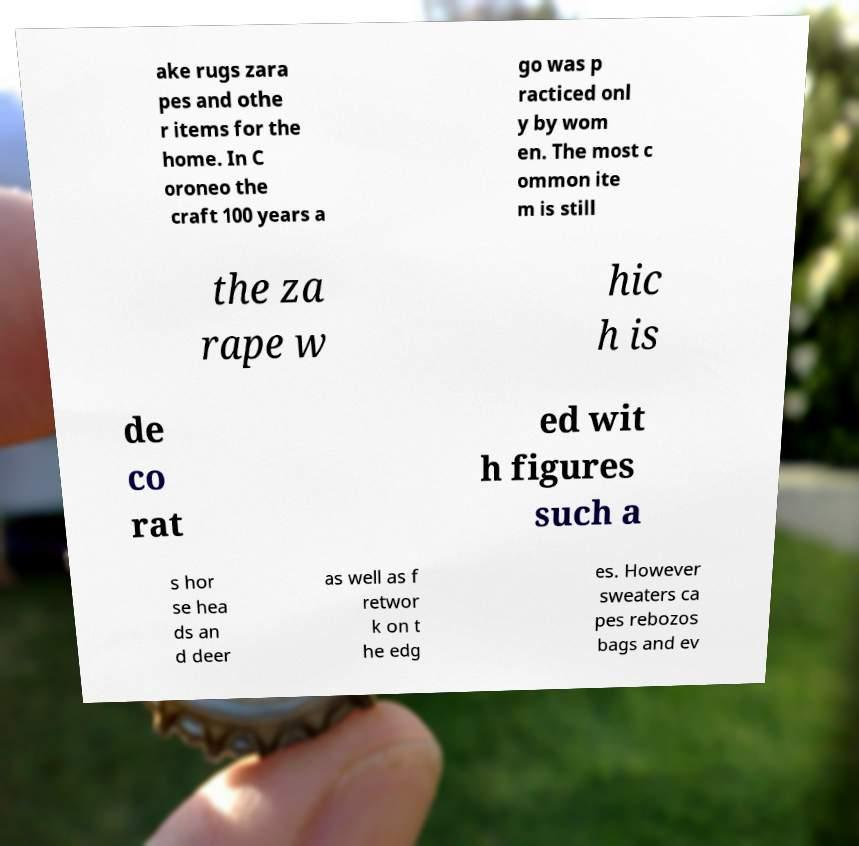Can you accurately transcribe the text from the provided image for me? ake rugs zara pes and othe r items for the home. In C oroneo the craft 100 years a go was p racticed onl y by wom en. The most c ommon ite m is still the za rape w hic h is de co rat ed wit h figures such a s hor se hea ds an d deer as well as f retwor k on t he edg es. However sweaters ca pes rebozos bags and ev 